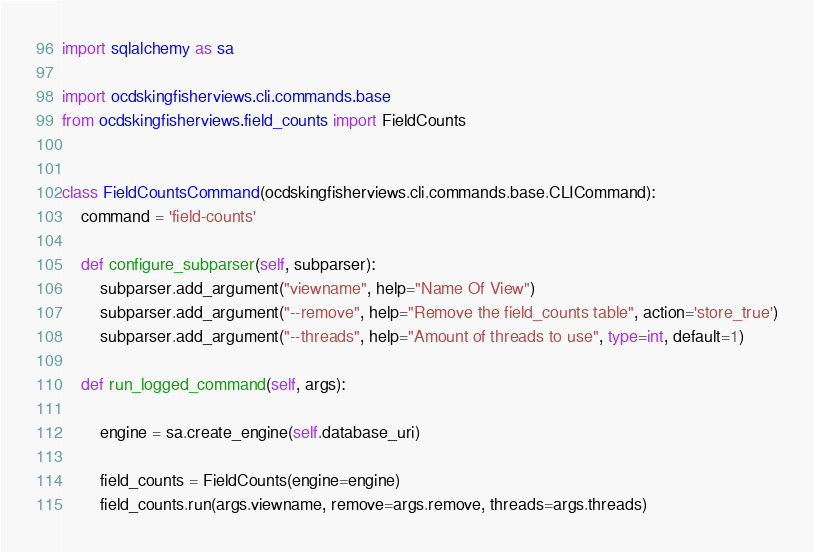<code> <loc_0><loc_0><loc_500><loc_500><_Python_>import sqlalchemy as sa

import ocdskingfisherviews.cli.commands.base
from ocdskingfisherviews.field_counts import FieldCounts


class FieldCountsCommand(ocdskingfisherviews.cli.commands.base.CLICommand):
    command = 'field-counts'

    def configure_subparser(self, subparser):
        subparser.add_argument("viewname", help="Name Of View")
        subparser.add_argument("--remove", help="Remove the field_counts table", action='store_true')
        subparser.add_argument("--threads", help="Amount of threads to use", type=int, default=1)

    def run_logged_command(self, args):

        engine = sa.create_engine(self.database_uri)

        field_counts = FieldCounts(engine=engine)
        field_counts.run(args.viewname, remove=args.remove, threads=args.threads)
</code> 